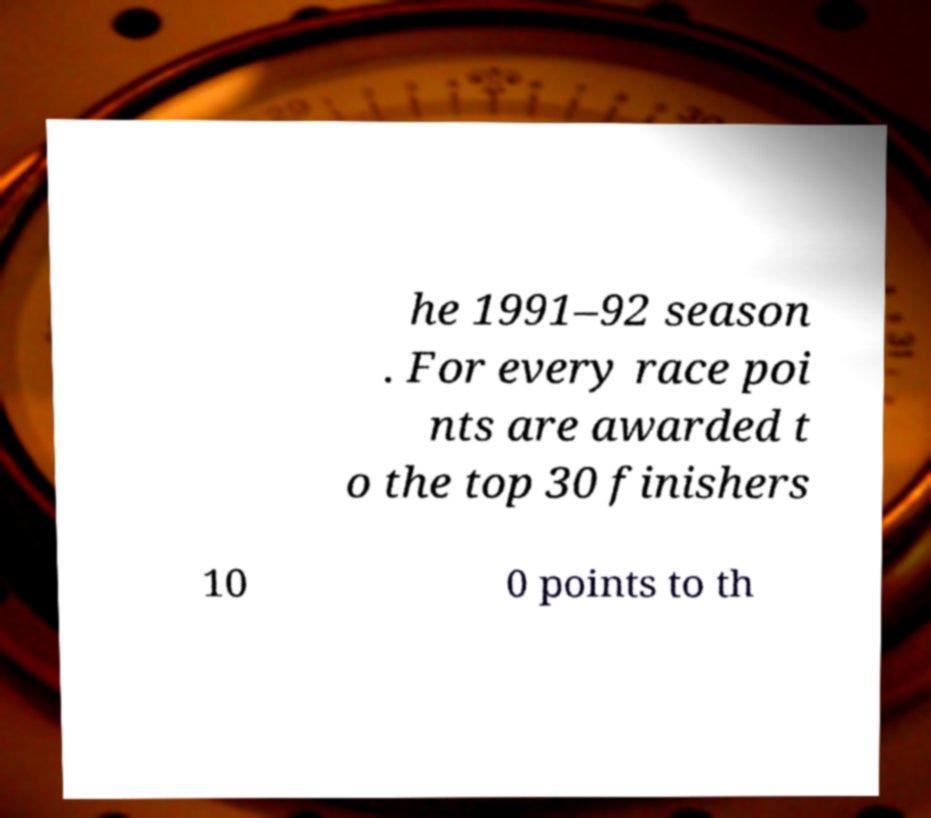I need the written content from this picture converted into text. Can you do that? he 1991–92 season . For every race poi nts are awarded t o the top 30 finishers 10 0 points to th 